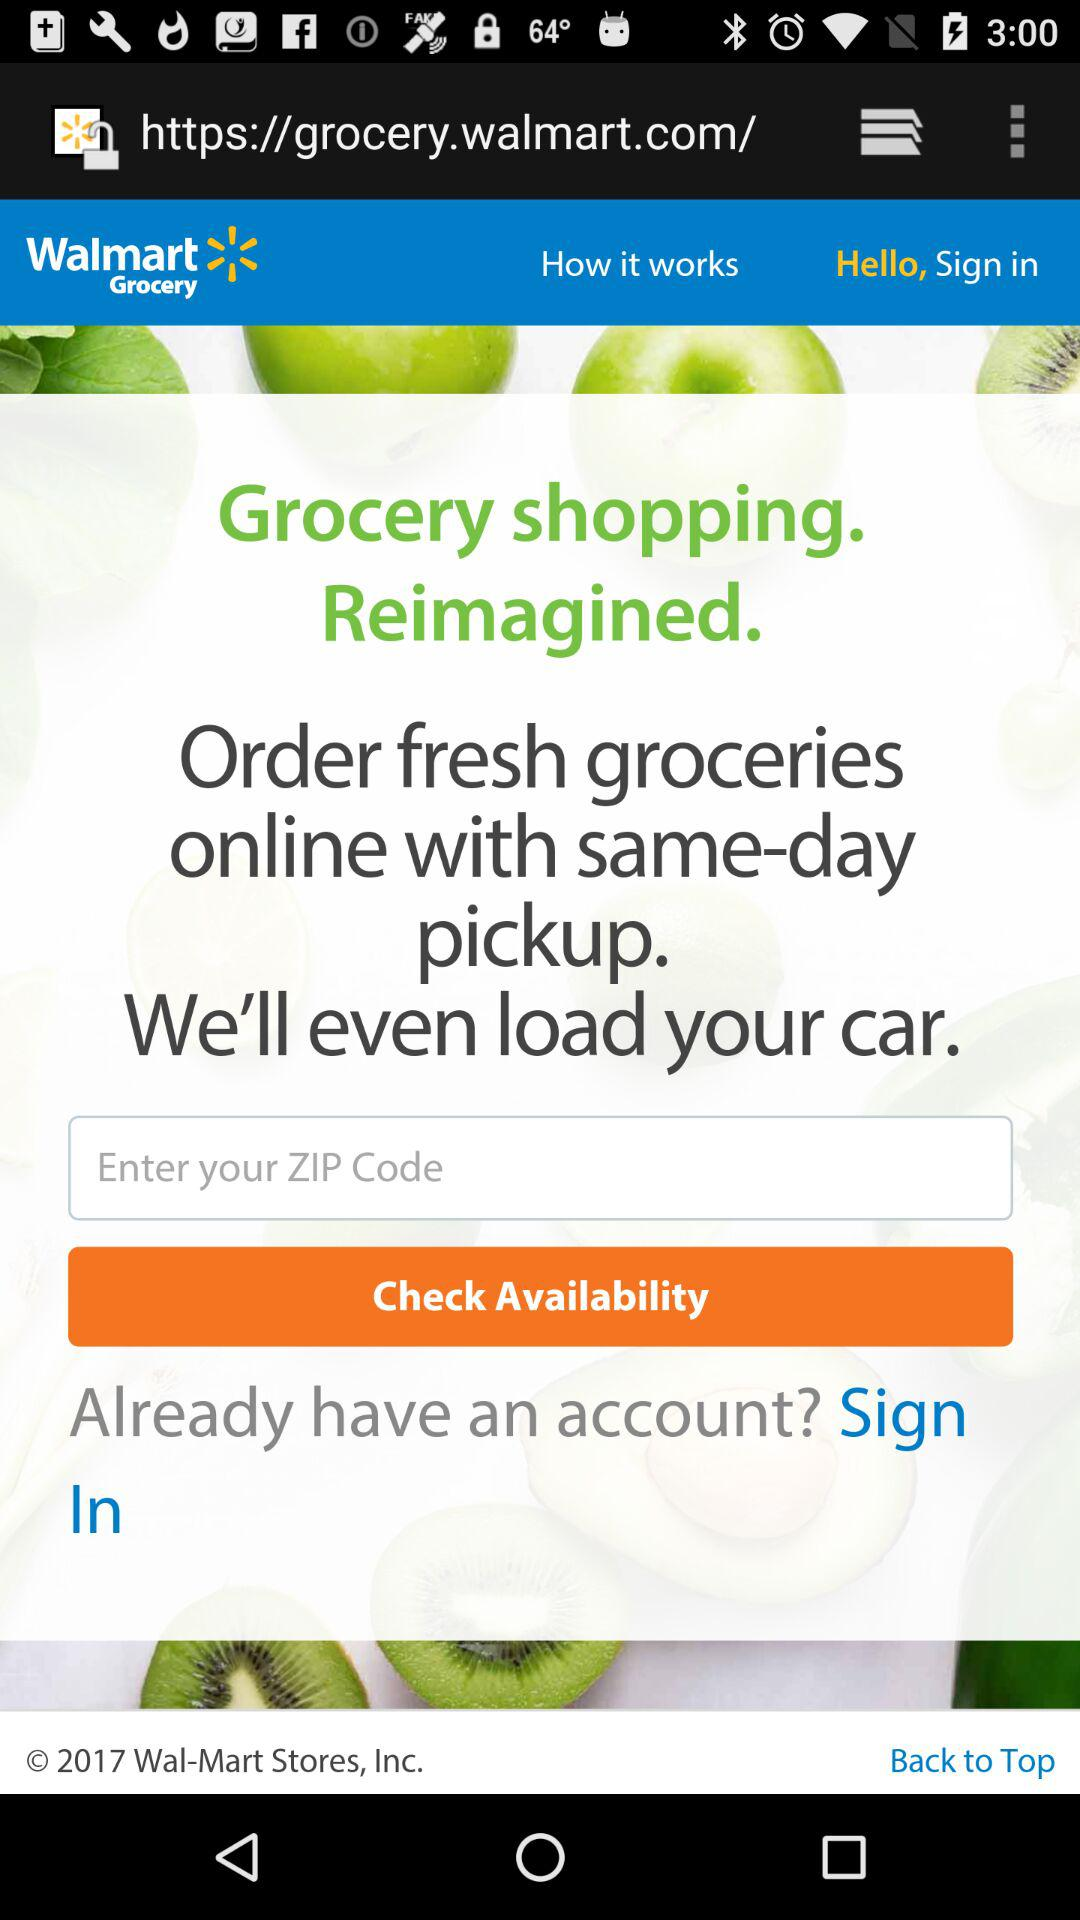What is the name of the application? The name of the application is "Walmart Grocery". 